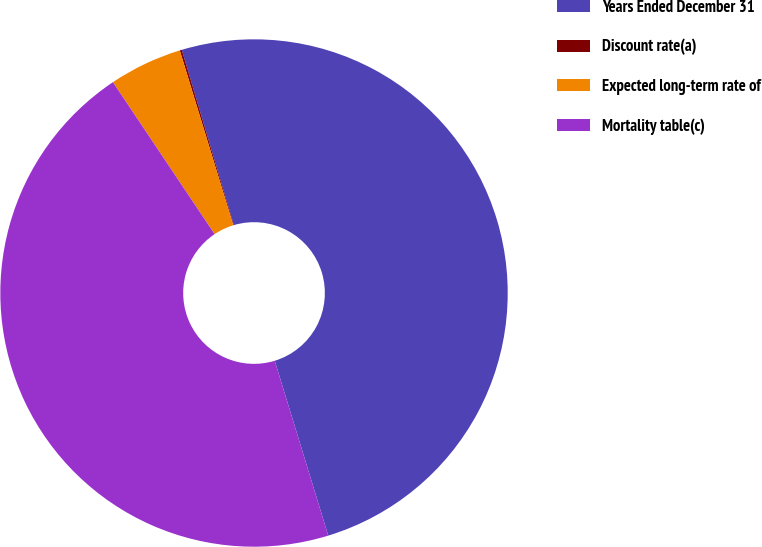Convert chart to OTSL. <chart><loc_0><loc_0><loc_500><loc_500><pie_chart><fcel>Years Ended December 31<fcel>Discount rate(a)<fcel>Expected long-term rate of<fcel>Mortality table(c)<nl><fcel>49.87%<fcel>0.13%<fcel>4.66%<fcel>45.34%<nl></chart> 